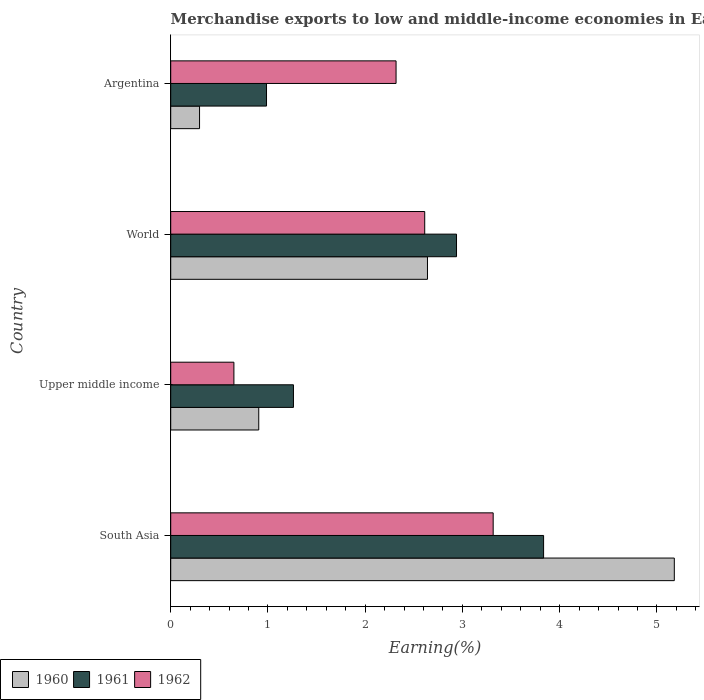Are the number of bars on each tick of the Y-axis equal?
Offer a terse response. Yes. How many bars are there on the 4th tick from the top?
Your answer should be compact. 3. How many bars are there on the 2nd tick from the bottom?
Provide a succinct answer. 3. What is the label of the 3rd group of bars from the top?
Offer a very short reply. Upper middle income. In how many cases, is the number of bars for a given country not equal to the number of legend labels?
Keep it short and to the point. 0. What is the percentage of amount earned from merchandise exports in 1960 in South Asia?
Your answer should be very brief. 5.18. Across all countries, what is the maximum percentage of amount earned from merchandise exports in 1961?
Your response must be concise. 3.83. Across all countries, what is the minimum percentage of amount earned from merchandise exports in 1960?
Your answer should be compact. 0.3. In which country was the percentage of amount earned from merchandise exports in 1961 maximum?
Provide a succinct answer. South Asia. In which country was the percentage of amount earned from merchandise exports in 1961 minimum?
Your answer should be very brief. Argentina. What is the total percentage of amount earned from merchandise exports in 1960 in the graph?
Keep it short and to the point. 9.02. What is the difference between the percentage of amount earned from merchandise exports in 1961 in Argentina and that in World?
Offer a very short reply. -1.95. What is the difference between the percentage of amount earned from merchandise exports in 1961 in South Asia and the percentage of amount earned from merchandise exports in 1960 in World?
Ensure brevity in your answer.  1.19. What is the average percentage of amount earned from merchandise exports in 1961 per country?
Give a very brief answer. 2.26. What is the difference between the percentage of amount earned from merchandise exports in 1962 and percentage of amount earned from merchandise exports in 1961 in Upper middle income?
Your response must be concise. -0.61. What is the ratio of the percentage of amount earned from merchandise exports in 1962 in Argentina to that in World?
Ensure brevity in your answer.  0.89. Is the percentage of amount earned from merchandise exports in 1961 in Argentina less than that in World?
Your response must be concise. Yes. Is the difference between the percentage of amount earned from merchandise exports in 1962 in Argentina and World greater than the difference between the percentage of amount earned from merchandise exports in 1961 in Argentina and World?
Offer a very short reply. Yes. What is the difference between the highest and the second highest percentage of amount earned from merchandise exports in 1960?
Your response must be concise. 2.54. What is the difference between the highest and the lowest percentage of amount earned from merchandise exports in 1960?
Provide a succinct answer. 4.88. Is the sum of the percentage of amount earned from merchandise exports in 1962 in Argentina and South Asia greater than the maximum percentage of amount earned from merchandise exports in 1960 across all countries?
Your response must be concise. Yes. Is it the case that in every country, the sum of the percentage of amount earned from merchandise exports in 1962 and percentage of amount earned from merchandise exports in 1960 is greater than the percentage of amount earned from merchandise exports in 1961?
Provide a succinct answer. Yes. How many bars are there?
Offer a very short reply. 12. Are all the bars in the graph horizontal?
Ensure brevity in your answer.  Yes. How many countries are there in the graph?
Your response must be concise. 4. What is the difference between two consecutive major ticks on the X-axis?
Make the answer very short. 1. Are the values on the major ticks of X-axis written in scientific E-notation?
Ensure brevity in your answer.  No. Does the graph contain any zero values?
Provide a short and direct response. No. Does the graph contain grids?
Your answer should be very brief. No. How many legend labels are there?
Your answer should be compact. 3. What is the title of the graph?
Make the answer very short. Merchandise exports to low and middle-income economies in East Asia & Pacific. Does "1967" appear as one of the legend labels in the graph?
Your answer should be compact. No. What is the label or title of the X-axis?
Keep it short and to the point. Earning(%). What is the label or title of the Y-axis?
Make the answer very short. Country. What is the Earning(%) in 1960 in South Asia?
Make the answer very short. 5.18. What is the Earning(%) in 1961 in South Asia?
Provide a succinct answer. 3.83. What is the Earning(%) of 1962 in South Asia?
Provide a succinct answer. 3.32. What is the Earning(%) in 1960 in Upper middle income?
Your answer should be compact. 0.91. What is the Earning(%) of 1961 in Upper middle income?
Keep it short and to the point. 1.26. What is the Earning(%) of 1962 in Upper middle income?
Ensure brevity in your answer.  0.65. What is the Earning(%) of 1960 in World?
Offer a terse response. 2.64. What is the Earning(%) in 1961 in World?
Offer a very short reply. 2.94. What is the Earning(%) of 1962 in World?
Your answer should be very brief. 2.61. What is the Earning(%) in 1960 in Argentina?
Provide a succinct answer. 0.3. What is the Earning(%) of 1961 in Argentina?
Give a very brief answer. 0.99. What is the Earning(%) of 1962 in Argentina?
Keep it short and to the point. 2.32. Across all countries, what is the maximum Earning(%) of 1960?
Offer a terse response. 5.18. Across all countries, what is the maximum Earning(%) in 1961?
Your answer should be very brief. 3.83. Across all countries, what is the maximum Earning(%) of 1962?
Make the answer very short. 3.32. Across all countries, what is the minimum Earning(%) of 1960?
Provide a short and direct response. 0.3. Across all countries, what is the minimum Earning(%) in 1961?
Your answer should be very brief. 0.99. Across all countries, what is the minimum Earning(%) in 1962?
Give a very brief answer. 0.65. What is the total Earning(%) in 1960 in the graph?
Offer a terse response. 9.02. What is the total Earning(%) in 1961 in the graph?
Your response must be concise. 9.02. What is the total Earning(%) in 1962 in the graph?
Offer a very short reply. 8.9. What is the difference between the Earning(%) of 1960 in South Asia and that in Upper middle income?
Ensure brevity in your answer.  4.27. What is the difference between the Earning(%) in 1961 in South Asia and that in Upper middle income?
Offer a very short reply. 2.57. What is the difference between the Earning(%) of 1962 in South Asia and that in Upper middle income?
Give a very brief answer. 2.67. What is the difference between the Earning(%) of 1960 in South Asia and that in World?
Your answer should be very brief. 2.54. What is the difference between the Earning(%) of 1961 in South Asia and that in World?
Offer a terse response. 0.9. What is the difference between the Earning(%) in 1962 in South Asia and that in World?
Keep it short and to the point. 0.7. What is the difference between the Earning(%) in 1960 in South Asia and that in Argentina?
Give a very brief answer. 4.88. What is the difference between the Earning(%) in 1961 in South Asia and that in Argentina?
Offer a terse response. 2.85. What is the difference between the Earning(%) in 1960 in Upper middle income and that in World?
Your response must be concise. -1.74. What is the difference between the Earning(%) of 1961 in Upper middle income and that in World?
Ensure brevity in your answer.  -1.68. What is the difference between the Earning(%) of 1962 in Upper middle income and that in World?
Ensure brevity in your answer.  -1.96. What is the difference between the Earning(%) in 1960 in Upper middle income and that in Argentina?
Give a very brief answer. 0.61. What is the difference between the Earning(%) of 1961 in Upper middle income and that in Argentina?
Your answer should be compact. 0.28. What is the difference between the Earning(%) in 1962 in Upper middle income and that in Argentina?
Make the answer very short. -1.67. What is the difference between the Earning(%) of 1960 in World and that in Argentina?
Offer a terse response. 2.34. What is the difference between the Earning(%) in 1961 in World and that in Argentina?
Provide a succinct answer. 1.95. What is the difference between the Earning(%) in 1962 in World and that in Argentina?
Your response must be concise. 0.29. What is the difference between the Earning(%) in 1960 in South Asia and the Earning(%) in 1961 in Upper middle income?
Make the answer very short. 3.92. What is the difference between the Earning(%) in 1960 in South Asia and the Earning(%) in 1962 in Upper middle income?
Give a very brief answer. 4.53. What is the difference between the Earning(%) of 1961 in South Asia and the Earning(%) of 1962 in Upper middle income?
Keep it short and to the point. 3.18. What is the difference between the Earning(%) of 1960 in South Asia and the Earning(%) of 1961 in World?
Keep it short and to the point. 2.24. What is the difference between the Earning(%) in 1960 in South Asia and the Earning(%) in 1962 in World?
Provide a short and direct response. 2.57. What is the difference between the Earning(%) of 1961 in South Asia and the Earning(%) of 1962 in World?
Ensure brevity in your answer.  1.22. What is the difference between the Earning(%) of 1960 in South Asia and the Earning(%) of 1961 in Argentina?
Your response must be concise. 4.19. What is the difference between the Earning(%) in 1960 in South Asia and the Earning(%) in 1962 in Argentina?
Ensure brevity in your answer.  2.86. What is the difference between the Earning(%) in 1961 in South Asia and the Earning(%) in 1962 in Argentina?
Offer a very short reply. 1.52. What is the difference between the Earning(%) in 1960 in Upper middle income and the Earning(%) in 1961 in World?
Your response must be concise. -2.03. What is the difference between the Earning(%) of 1960 in Upper middle income and the Earning(%) of 1962 in World?
Your response must be concise. -1.71. What is the difference between the Earning(%) of 1961 in Upper middle income and the Earning(%) of 1962 in World?
Give a very brief answer. -1.35. What is the difference between the Earning(%) of 1960 in Upper middle income and the Earning(%) of 1961 in Argentina?
Give a very brief answer. -0.08. What is the difference between the Earning(%) of 1960 in Upper middle income and the Earning(%) of 1962 in Argentina?
Make the answer very short. -1.41. What is the difference between the Earning(%) in 1961 in Upper middle income and the Earning(%) in 1962 in Argentina?
Provide a succinct answer. -1.06. What is the difference between the Earning(%) in 1960 in World and the Earning(%) in 1961 in Argentina?
Offer a terse response. 1.66. What is the difference between the Earning(%) of 1960 in World and the Earning(%) of 1962 in Argentina?
Your response must be concise. 0.32. What is the difference between the Earning(%) in 1961 in World and the Earning(%) in 1962 in Argentina?
Ensure brevity in your answer.  0.62. What is the average Earning(%) of 1960 per country?
Offer a very short reply. 2.26. What is the average Earning(%) in 1961 per country?
Give a very brief answer. 2.26. What is the average Earning(%) of 1962 per country?
Your answer should be very brief. 2.22. What is the difference between the Earning(%) in 1960 and Earning(%) in 1961 in South Asia?
Provide a succinct answer. 1.34. What is the difference between the Earning(%) of 1960 and Earning(%) of 1962 in South Asia?
Keep it short and to the point. 1.86. What is the difference between the Earning(%) in 1961 and Earning(%) in 1962 in South Asia?
Keep it short and to the point. 0.52. What is the difference between the Earning(%) of 1960 and Earning(%) of 1961 in Upper middle income?
Ensure brevity in your answer.  -0.36. What is the difference between the Earning(%) of 1960 and Earning(%) of 1962 in Upper middle income?
Offer a very short reply. 0.26. What is the difference between the Earning(%) in 1961 and Earning(%) in 1962 in Upper middle income?
Make the answer very short. 0.61. What is the difference between the Earning(%) in 1960 and Earning(%) in 1961 in World?
Your answer should be compact. -0.3. What is the difference between the Earning(%) of 1960 and Earning(%) of 1962 in World?
Your answer should be compact. 0.03. What is the difference between the Earning(%) in 1961 and Earning(%) in 1962 in World?
Provide a succinct answer. 0.33. What is the difference between the Earning(%) of 1960 and Earning(%) of 1961 in Argentina?
Offer a very short reply. -0.69. What is the difference between the Earning(%) of 1960 and Earning(%) of 1962 in Argentina?
Your answer should be very brief. -2.02. What is the difference between the Earning(%) of 1961 and Earning(%) of 1962 in Argentina?
Keep it short and to the point. -1.33. What is the ratio of the Earning(%) of 1960 in South Asia to that in Upper middle income?
Make the answer very short. 5.72. What is the ratio of the Earning(%) in 1961 in South Asia to that in Upper middle income?
Your response must be concise. 3.04. What is the ratio of the Earning(%) of 1962 in South Asia to that in Upper middle income?
Offer a terse response. 5.1. What is the ratio of the Earning(%) of 1960 in South Asia to that in World?
Your answer should be very brief. 1.96. What is the ratio of the Earning(%) of 1961 in South Asia to that in World?
Your answer should be very brief. 1.3. What is the ratio of the Earning(%) in 1962 in South Asia to that in World?
Offer a very short reply. 1.27. What is the ratio of the Earning(%) of 1960 in South Asia to that in Argentina?
Give a very brief answer. 17.46. What is the ratio of the Earning(%) of 1961 in South Asia to that in Argentina?
Offer a terse response. 3.89. What is the ratio of the Earning(%) of 1962 in South Asia to that in Argentina?
Your answer should be compact. 1.43. What is the ratio of the Earning(%) of 1960 in Upper middle income to that in World?
Make the answer very short. 0.34. What is the ratio of the Earning(%) of 1961 in Upper middle income to that in World?
Keep it short and to the point. 0.43. What is the ratio of the Earning(%) of 1962 in Upper middle income to that in World?
Offer a terse response. 0.25. What is the ratio of the Earning(%) in 1960 in Upper middle income to that in Argentina?
Give a very brief answer. 3.05. What is the ratio of the Earning(%) in 1961 in Upper middle income to that in Argentina?
Your answer should be compact. 1.28. What is the ratio of the Earning(%) of 1962 in Upper middle income to that in Argentina?
Your answer should be compact. 0.28. What is the ratio of the Earning(%) of 1960 in World to that in Argentina?
Ensure brevity in your answer.  8.9. What is the ratio of the Earning(%) of 1961 in World to that in Argentina?
Offer a very short reply. 2.98. What is the ratio of the Earning(%) in 1962 in World to that in Argentina?
Give a very brief answer. 1.13. What is the difference between the highest and the second highest Earning(%) of 1960?
Provide a succinct answer. 2.54. What is the difference between the highest and the second highest Earning(%) in 1961?
Ensure brevity in your answer.  0.9. What is the difference between the highest and the second highest Earning(%) in 1962?
Your answer should be compact. 0.7. What is the difference between the highest and the lowest Earning(%) of 1960?
Ensure brevity in your answer.  4.88. What is the difference between the highest and the lowest Earning(%) of 1961?
Your answer should be compact. 2.85. What is the difference between the highest and the lowest Earning(%) of 1962?
Make the answer very short. 2.67. 